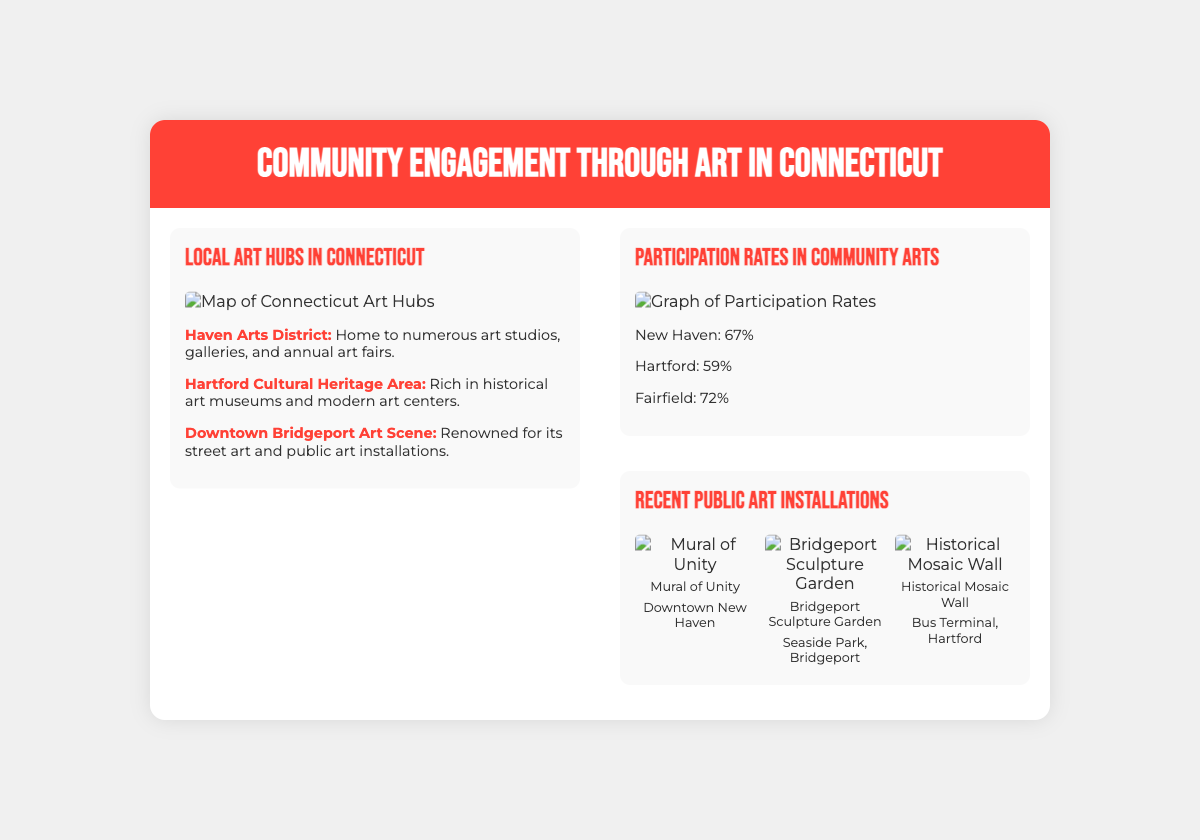What is the title of the presentation? The title of the presentation is mentioned prominently at the top of the slide.
Answer: Community Engagement through Art in Connecticut Which city has the highest participation rate in community arts? The participation rates are provided for several cities, and the highest rate can be identified directly.
Answer: Fairfield What is the name of the mural in Downtown New Haven? The specific name of the mural is mentioned below its image in the visual section.
Answer: Mural of Unity Which art district is home to numerous galleries and art fairs? The information is provided in the map details section about a specific art district.
Answer: Haven Arts District How many public art installations are showcased in the visual section? The document displays a grid of visual items representing public art installations.
Answer: 3 What percentage of participation is reported for New Haven? The percentage for community arts participation in New Haven is listed in the graph section.
Answer: 67% Which park features the Bridgeport Sculpture Garden? The location of the Bridgeport Sculpture Garden is described in the visual item details.
Answer: Seaside Park What color is the header background of the slide? The background color of the header is described in the styling details.
Answer: Red 